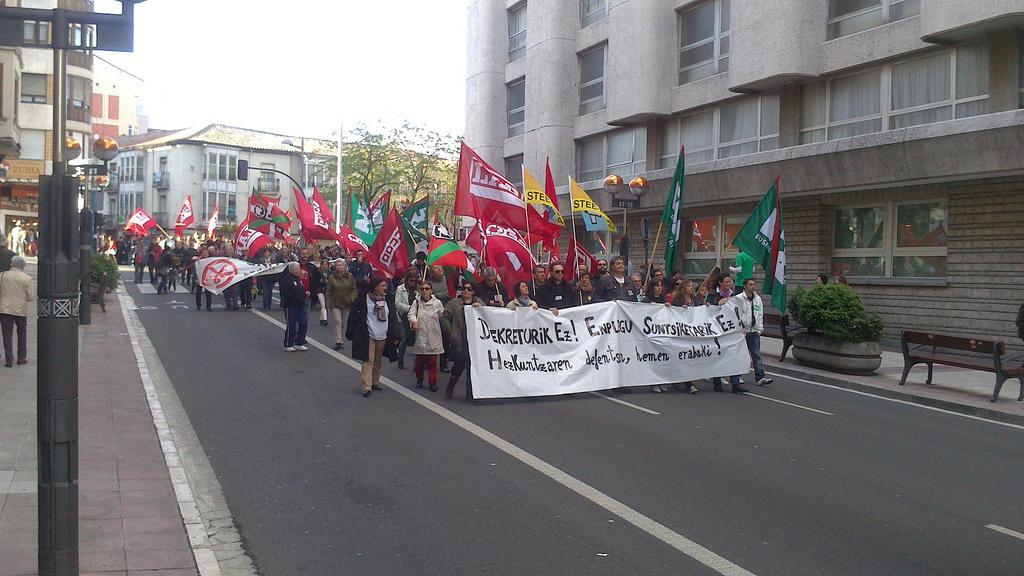In one or two sentences, can you explain what this image depicts? The picture is taken in the middle of the road. There are few people walking in the front are holding banner the back people are holding flags. In the middle here there is another banner. There are benches and plants on the side of the road. There are buildings and trees in the background. 